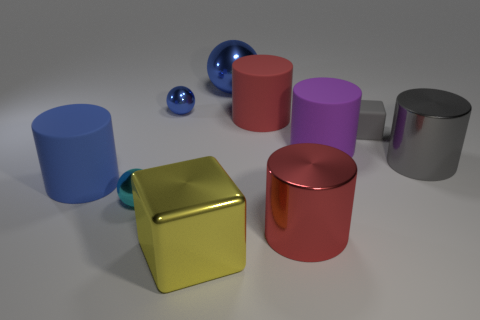Is the big blue matte object the same shape as the red matte object?
Your answer should be compact. Yes. How many yellow cylinders have the same size as the yellow metal cube?
Make the answer very short. 0. Are there fewer large red cylinders behind the small cyan ball than tiny yellow things?
Give a very brief answer. No. There is a blue shiny thing that is to the left of the blue metal object behind the small blue object; what is its size?
Your answer should be very brief. Small. What number of objects are either small matte blocks or gray shiny things?
Make the answer very short. 2. Are there any large shiny balls that have the same color as the tiny block?
Offer a terse response. No. Are there fewer tiny gray matte spheres than purple matte cylinders?
Offer a very short reply. Yes. What number of objects are either large gray shiny things or big objects that are to the right of the yellow thing?
Make the answer very short. 5. Is there a big blue object made of the same material as the tiny gray thing?
Provide a succinct answer. Yes. What material is the blue cylinder that is the same size as the gray metal cylinder?
Offer a terse response. Rubber. 